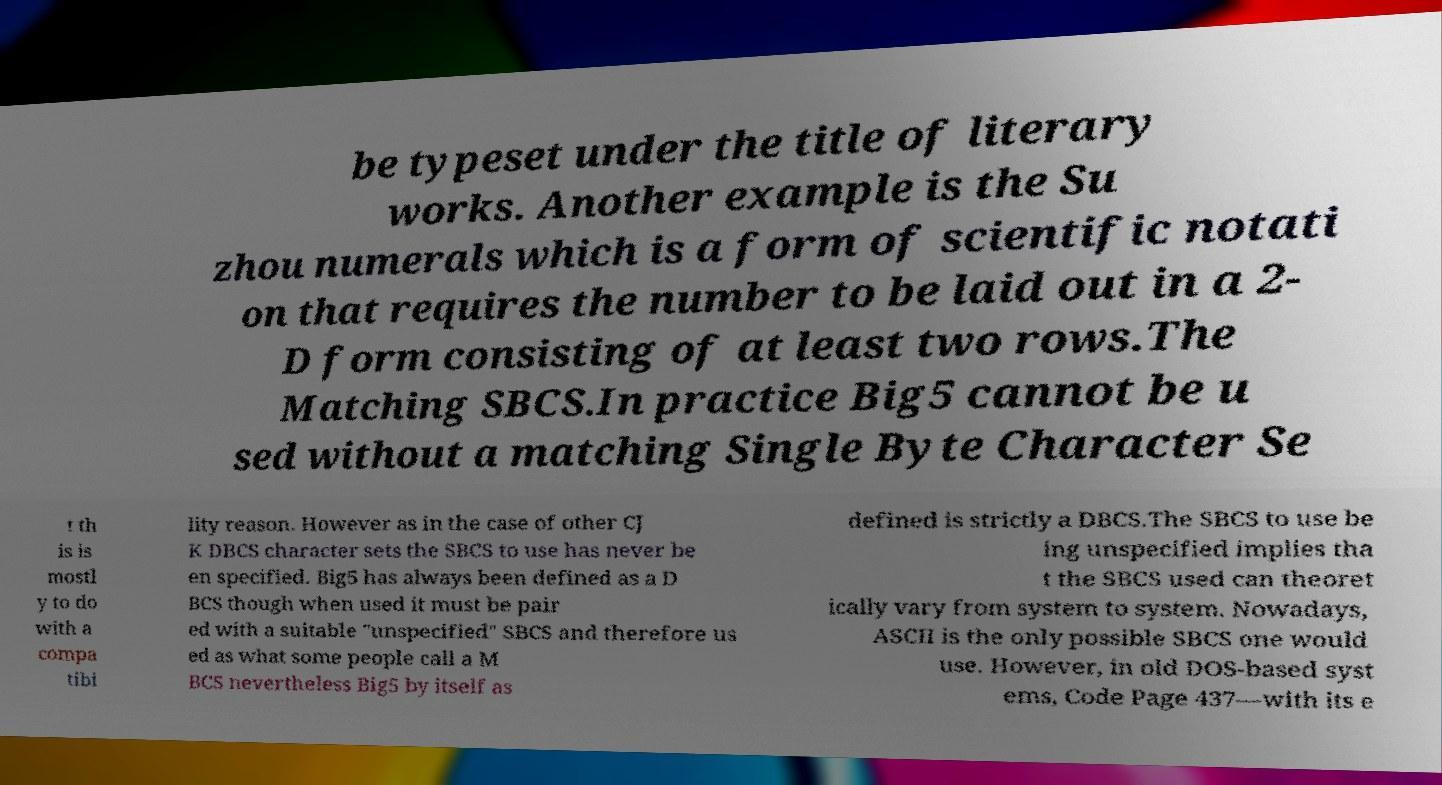Could you extract and type out the text from this image? be typeset under the title of literary works. Another example is the Su zhou numerals which is a form of scientific notati on that requires the number to be laid out in a 2- D form consisting of at least two rows.The Matching SBCS.In practice Big5 cannot be u sed without a matching Single Byte Character Se t th is is mostl y to do with a compa tibi lity reason. However as in the case of other CJ K DBCS character sets the SBCS to use has never be en specified. Big5 has always been defined as a D BCS though when used it must be pair ed with a suitable "unspecified" SBCS and therefore us ed as what some people call a M BCS nevertheless Big5 by itself as defined is strictly a DBCS.The SBCS to use be ing unspecified implies tha t the SBCS used can theoret ically vary from system to system. Nowadays, ASCII is the only possible SBCS one would use. However, in old DOS-based syst ems, Code Page 437—with its e 